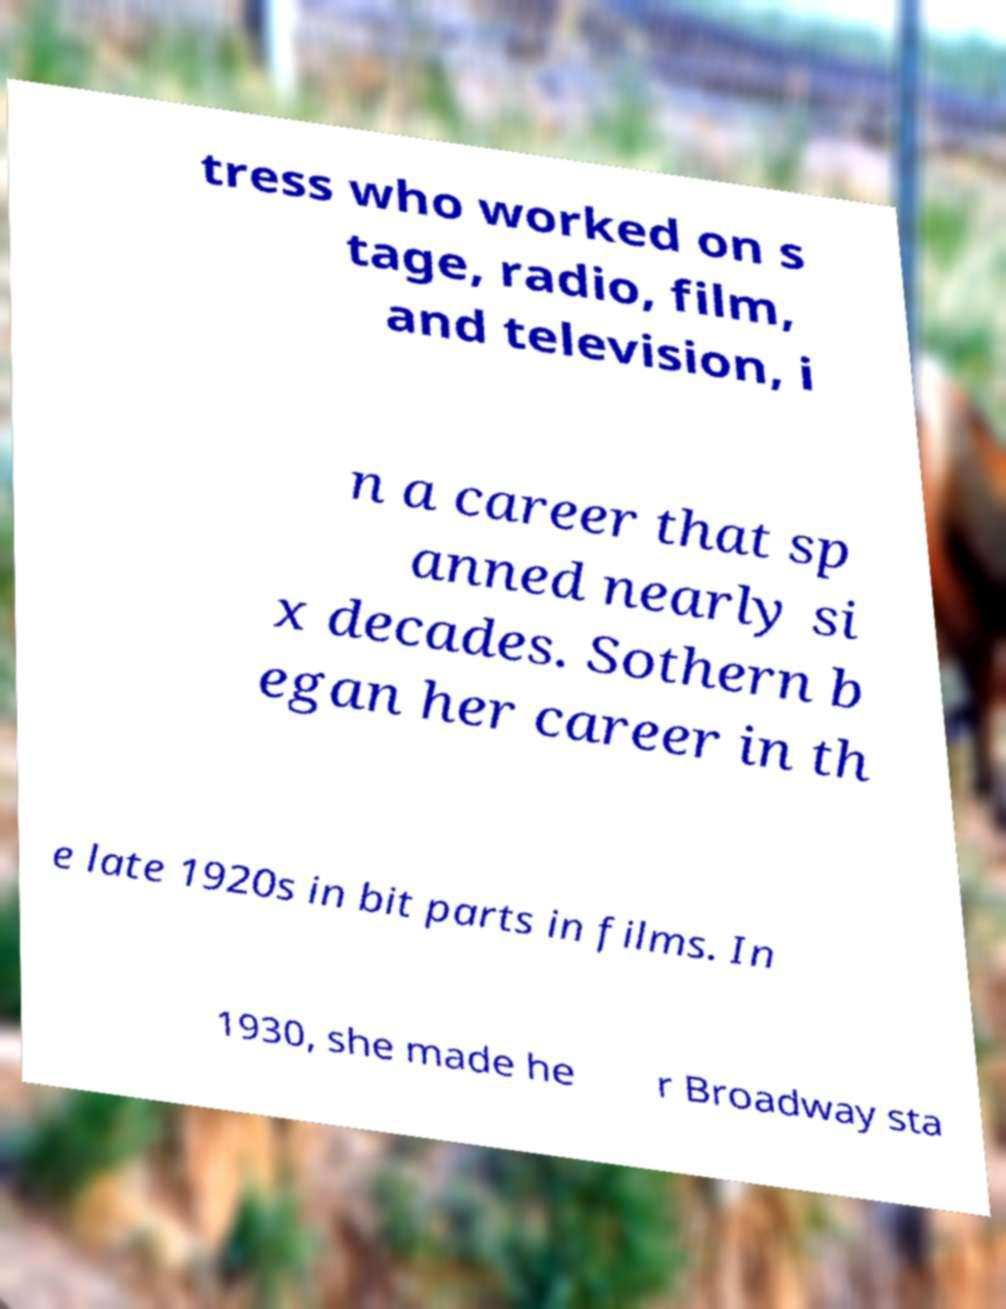Can you read and provide the text displayed in the image?This photo seems to have some interesting text. Can you extract and type it out for me? tress who worked on s tage, radio, film, and television, i n a career that sp anned nearly si x decades. Sothern b egan her career in th e late 1920s in bit parts in films. In 1930, she made he r Broadway sta 